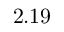Convert formula to latex. <formula><loc_0><loc_0><loc_500><loc_500>2 . 1 9</formula> 